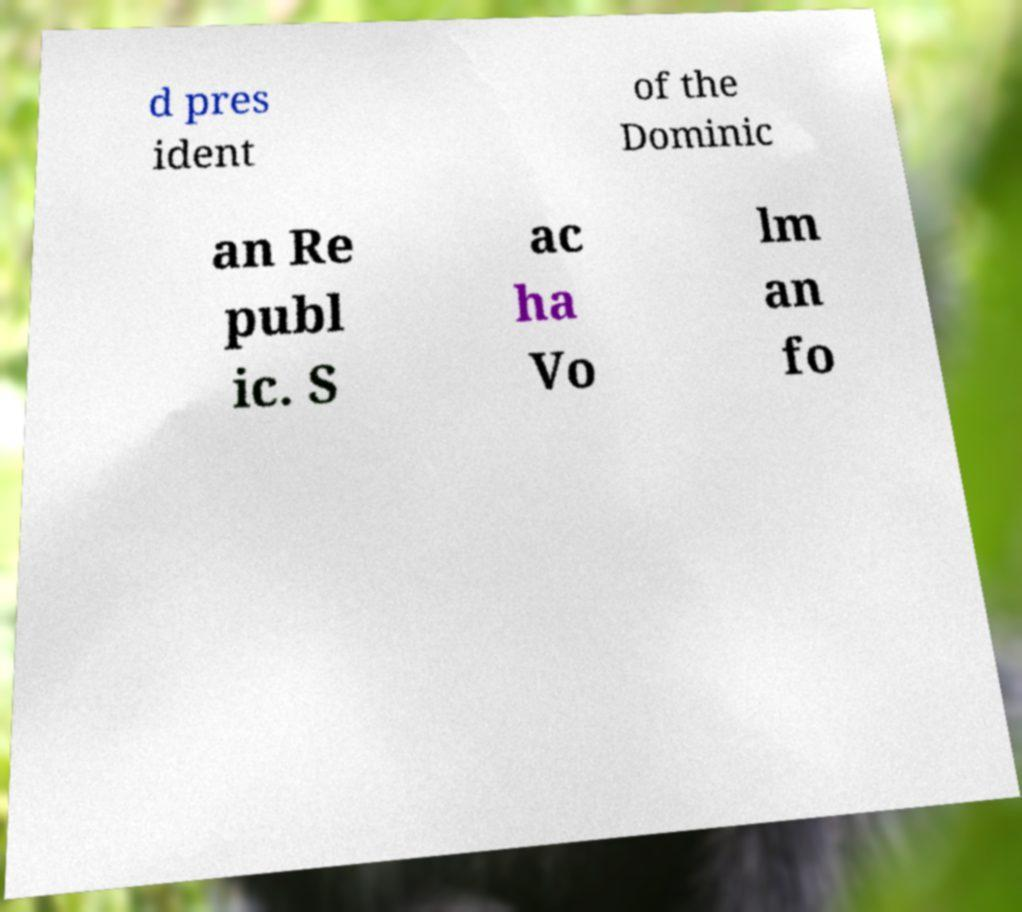Please identify and transcribe the text found in this image. d pres ident of the Dominic an Re publ ic. S ac ha Vo lm an fo 